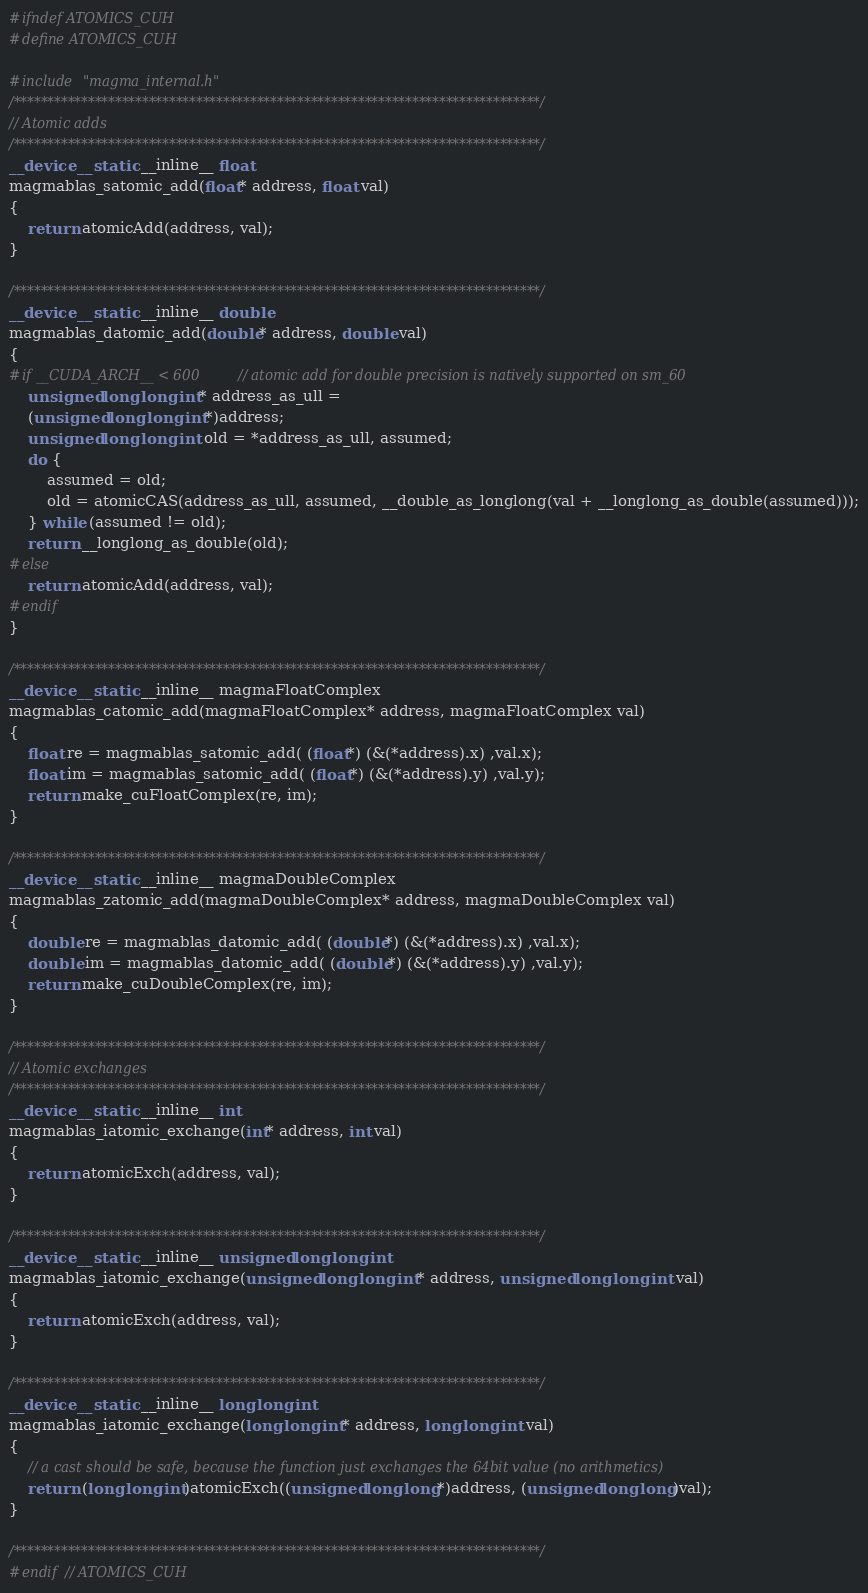Convert code to text. <code><loc_0><loc_0><loc_500><loc_500><_Cuda_>#ifndef ATOMICS_CUH
#define ATOMICS_CUH

#include "magma_internal.h"
/******************************************************************************/
// Atomic adds 
/******************************************************************************/
__device__ static __inline__ float 
magmablas_satomic_add(float* address, float val)
{
    return atomicAdd(address, val);
}

/******************************************************************************/
__device__ static __inline__ double 
magmablas_datomic_add(double* address, double val)
{
#if __CUDA_ARCH__ < 600    // atomic add for double precision is natively supported on sm_60
    unsigned long long int* address_as_ull =
    (unsigned long long int*)address;
    unsigned long long int old = *address_as_ull, assumed;
    do {
        assumed = old;
        old = atomicCAS(address_as_ull, assumed, __double_as_longlong(val + __longlong_as_double(assumed)));
    } while (assumed != old);
    return __longlong_as_double(old);
#else
    return atomicAdd(address, val);
#endif
}

/******************************************************************************/
__device__ static __inline__ magmaFloatComplex 
magmablas_catomic_add(magmaFloatComplex* address, magmaFloatComplex val)
{
    float re = magmablas_satomic_add( (float*) (&(*address).x) ,val.x);
    float im = magmablas_satomic_add( (float*) (&(*address).y) ,val.y);
    return make_cuFloatComplex(re, im);
}

/******************************************************************************/
__device__ static __inline__ magmaDoubleComplex 
magmablas_zatomic_add(magmaDoubleComplex* address, magmaDoubleComplex val)
{
    double re = magmablas_datomic_add( (double*) (&(*address).x) ,val.x);
    double im = magmablas_datomic_add( (double*) (&(*address).y) ,val.y);
    return make_cuDoubleComplex(re, im);
}

/******************************************************************************/
// Atomic exchanges 
/******************************************************************************/
__device__ static __inline__ int 
magmablas_iatomic_exchange(int* address, int val)
{
    return atomicExch(address, val);
}

/******************************************************************************/
__device__ static __inline__ unsigned long long int 
magmablas_iatomic_exchange(unsigned long long int* address, unsigned long long int val)
{
    return atomicExch(address, val);
}

/******************************************************************************/
__device__ static __inline__ long long int 
magmablas_iatomic_exchange(long long int* address, long long int val)
{
    // a cast should be safe, because the function just exchanges the 64bit value (no arithmetics)
    return (long long int)atomicExch((unsigned long long*)address, (unsigned long long)val);
}

/******************************************************************************/
#endif // ATOMICS_CUH
</code> 